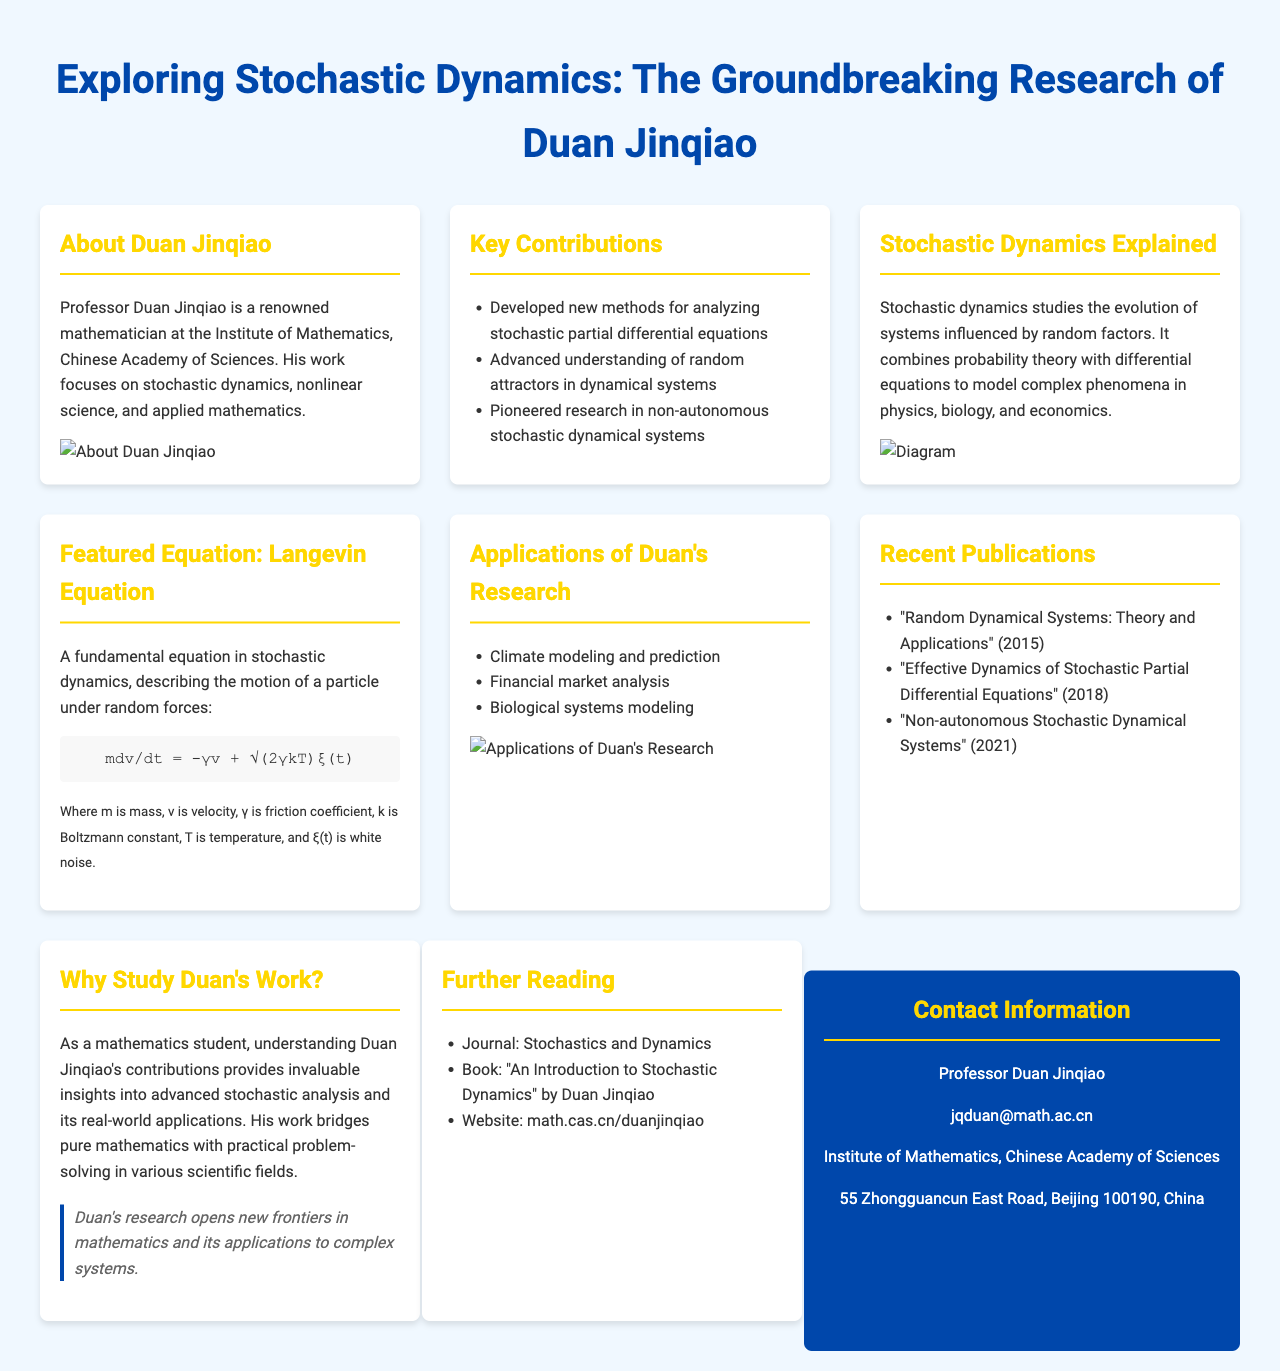what is the title of the brochure? The title of the brochure is prominently displayed at the top of the document.
Answer: Exploring Stochastic Dynamics: The Groundbreaking Research of Duan Jinqiao who is the main subject of the research presented? The main subject of the research contributions is mentioned in the first section of the brochure.
Answer: Duan Jinqiao what type of dynamics does Duan Jinqiao focus on? The brochure specifically states the field of study in which Duan Jinqiao specializes.
Answer: Stochastic dynamics what year was the publication "Effective Dynamics of Stochastic Partial Differential Equations" released? The publication year of this specific work is listed in the section for recent publications.
Answer: 2018 name one application of Duan's research mentioned in the brochure. The brochure lists several applications under the section dedicated to them.
Answer: Climate modeling and prediction how many key contributions of Duan Jinqiao are listed? The number of key contributions is indicated by the bullet points in the respective section.
Answer: Three what does the featured equation describe? The context about the featured equation provides information about its application in stochastic dynamics.
Answer: Motion of a particle under random forces which journal is recommended for further reading? The recommendation for further reading includes specific journals and books in the document.
Answer: Stochastics and Dynamics how is Duan Jinqiao's work characterized in the brochure? The last section provides insight into the value of studying Duan's contributions.
Answer: Opens new frontiers in mathematics and its applications to complex systems 